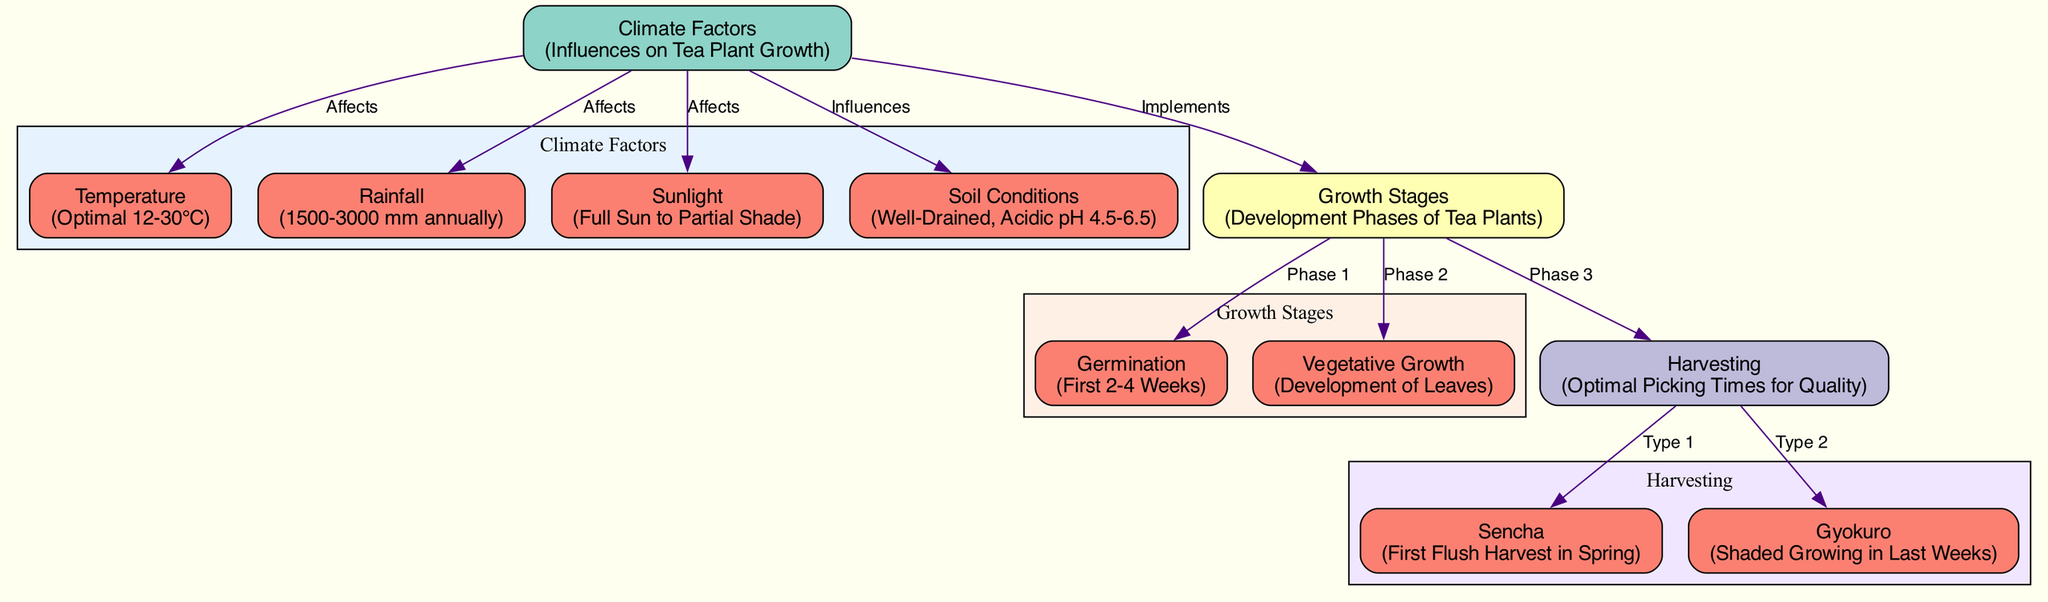What are the optimal temperature conditions for tea plant growth? The diagram indicates that the optimal temperature for tea plant growth is between 12 to 30 degrees Celsius, which is specified under the "Temperature" node.
Answer: 12-30°C How many main climate factors affect tea plant growth? The diagram shows the "Climate Factors" node leads to four distinct nodes: temperature, rainfall, sunlight, and soil conditions, meaning there are four main climate factors.
Answer: 4 What is the annual rainfall range needed for tea plants? The diagram specifies that the rainfall range required annually for tea plants is between 1500 to 3000 millimeters, detailed in the "Rainfall" node.
Answer: 1500-3000 mm Which growth stage comes after germination? Looking at the "Growth Stages" node, it is clear that "Vegetative Growth" follows "Germination," as indicated by the directed edge labeled "Phase 1."
Answer: Vegetative Growth What type of tea is harvested during the first flush in spring? The diagram points to the relationship where "Sencha" is identified under the "Harvesting" node as the type of tea associated with the first flush harvest in spring.
Answer: Sencha Which climate factor influences soil conditions? According to the diagram, the edge labeled "Influences" from "Climate Factors" to "Soil Conditions" indicates that soil conditions are influenced by climate factors.
Answer: Climate Factors What is the relationship between harvesting and gyokuro? The diagram shows an edge from "Harvesting" to "Gyokuro," labeled "Type 2," indicating that gyokuro is related to the harvesting stage of tea plants.
Answer: Gyokuro What is the phase of growth where leaves develop? The "Vegetative Growth" node under the "Growth Stages" section specifically describes the phase where the development of leaves occurs.
Answer: Vegetative Growth How many distinct harvesting types are mentioned in the diagram? In the diagram, there are two types of harvesting identified: Sencha and Gyokuro, indicated by the edges extending from the "Harvesting" node.
Answer: 2 